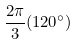<formula> <loc_0><loc_0><loc_500><loc_500>\frac { 2 \pi } { 3 } ( 1 2 0 ^ { \circ } )</formula> 